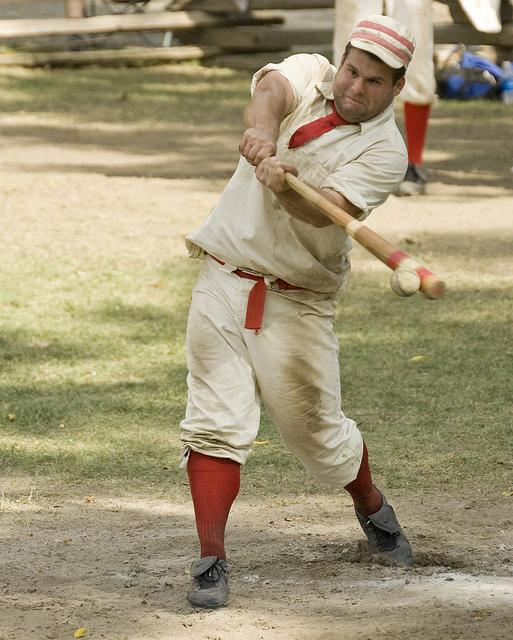Which country headquarters the brand company of this man's shoes?

Choices:
A) china
B) india
C) united states
D) italy united states 